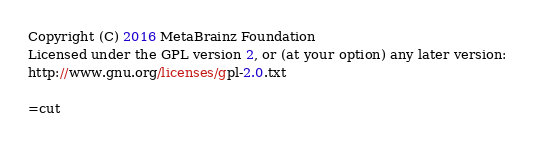<code> <loc_0><loc_0><loc_500><loc_500><_Perl_>Copyright (C) 2016 MetaBrainz Foundation
Licensed under the GPL version 2, or (at your option) any later version:
http://www.gnu.org/licenses/gpl-2.0.txt

=cut
</code> 